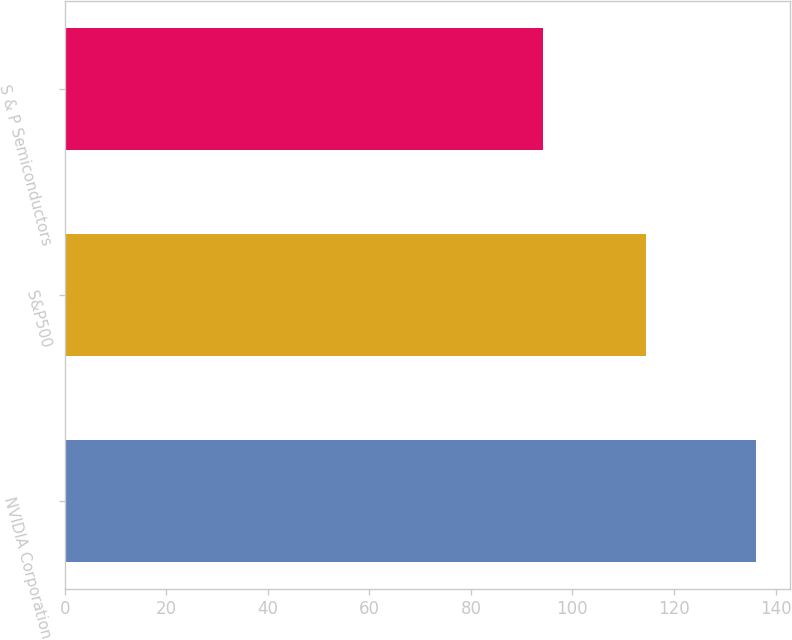Convert chart. <chart><loc_0><loc_0><loc_500><loc_500><bar_chart><fcel>NVIDIA Corporation<fcel>S&P500<fcel>S & P Semiconductors<nl><fcel>136.09<fcel>114.51<fcel>94.16<nl></chart> 